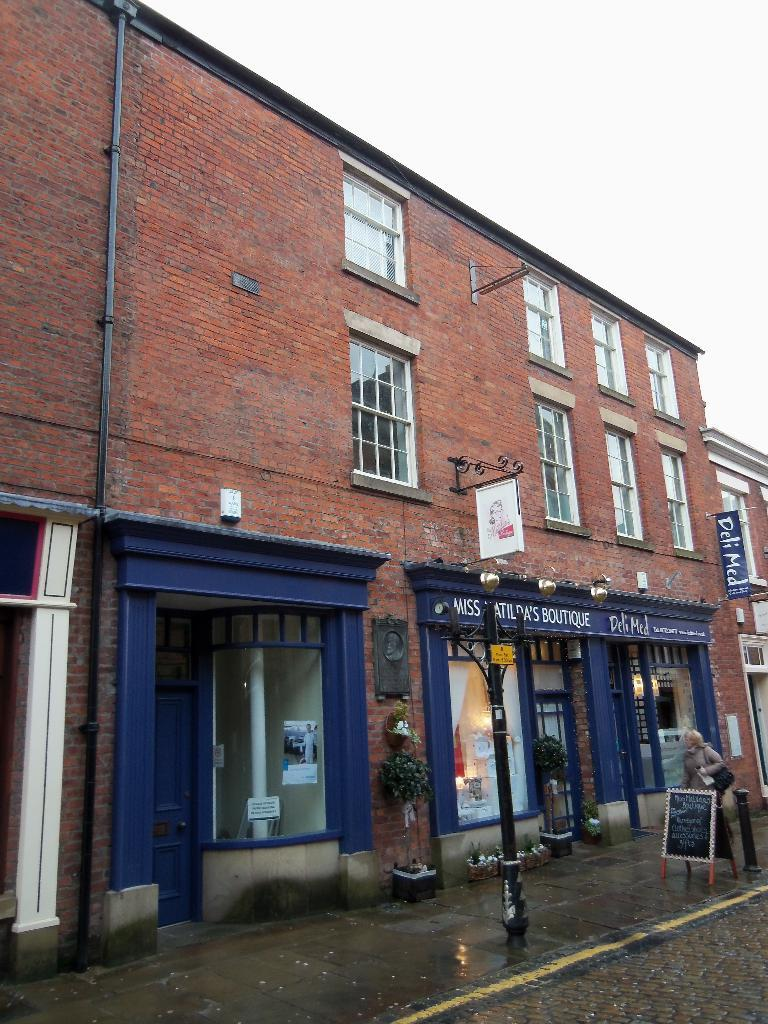What type of structure is in the image? There is a building in the image. What is located beneath the building? There are stores under the building. What can be seen in the foreground of the image? There is a path in the foreground of the image. What is present on the path? Plants and a street light are visible on the path. What else can be found on the path? There is a board on the path. What type of punishment is being administered to the boat in the image? There is no boat present in the image, and therefore no punishment can be observed. What type of apparel is being sold in the stores under the building? The provided facts do not mention the type of stores or the products they sell, so we cannot determine what type of apparel is being sold. 